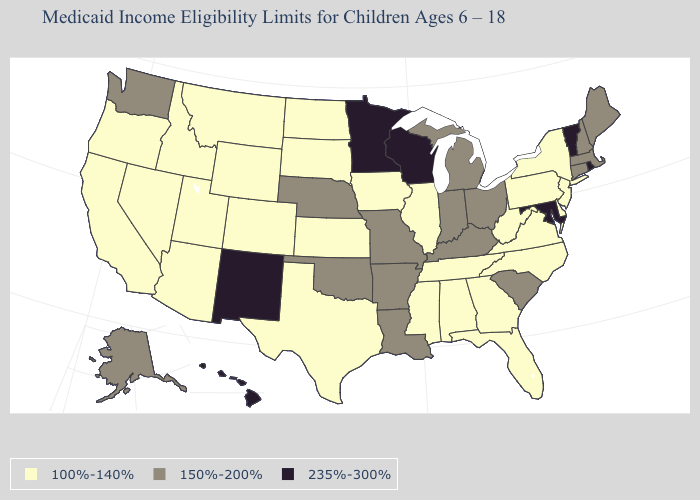Among the states that border Oklahoma , does Colorado have the lowest value?
Answer briefly. Yes. What is the lowest value in the USA?
Quick response, please. 100%-140%. Is the legend a continuous bar?
Write a very short answer. No. Name the states that have a value in the range 235%-300%?
Keep it brief. Hawaii, Maryland, Minnesota, New Mexico, Rhode Island, Vermont, Wisconsin. Does the map have missing data?
Short answer required. No. Name the states that have a value in the range 235%-300%?
Answer briefly. Hawaii, Maryland, Minnesota, New Mexico, Rhode Island, Vermont, Wisconsin. Name the states that have a value in the range 100%-140%?
Concise answer only. Alabama, Arizona, California, Colorado, Delaware, Florida, Georgia, Idaho, Illinois, Iowa, Kansas, Mississippi, Montana, Nevada, New Jersey, New York, North Carolina, North Dakota, Oregon, Pennsylvania, South Dakota, Tennessee, Texas, Utah, Virginia, West Virginia, Wyoming. Among the states that border Oklahoma , which have the highest value?
Keep it brief. New Mexico. Name the states that have a value in the range 100%-140%?
Be succinct. Alabama, Arizona, California, Colorado, Delaware, Florida, Georgia, Idaho, Illinois, Iowa, Kansas, Mississippi, Montana, Nevada, New Jersey, New York, North Carolina, North Dakota, Oregon, Pennsylvania, South Dakota, Tennessee, Texas, Utah, Virginia, West Virginia, Wyoming. What is the value of Arkansas?
Keep it brief. 150%-200%. What is the value of Arizona?
Be succinct. 100%-140%. What is the value of Utah?
Keep it brief. 100%-140%. Name the states that have a value in the range 150%-200%?
Give a very brief answer. Alaska, Arkansas, Connecticut, Indiana, Kentucky, Louisiana, Maine, Massachusetts, Michigan, Missouri, Nebraska, New Hampshire, Ohio, Oklahoma, South Carolina, Washington. What is the value of New Mexico?
Concise answer only. 235%-300%. 